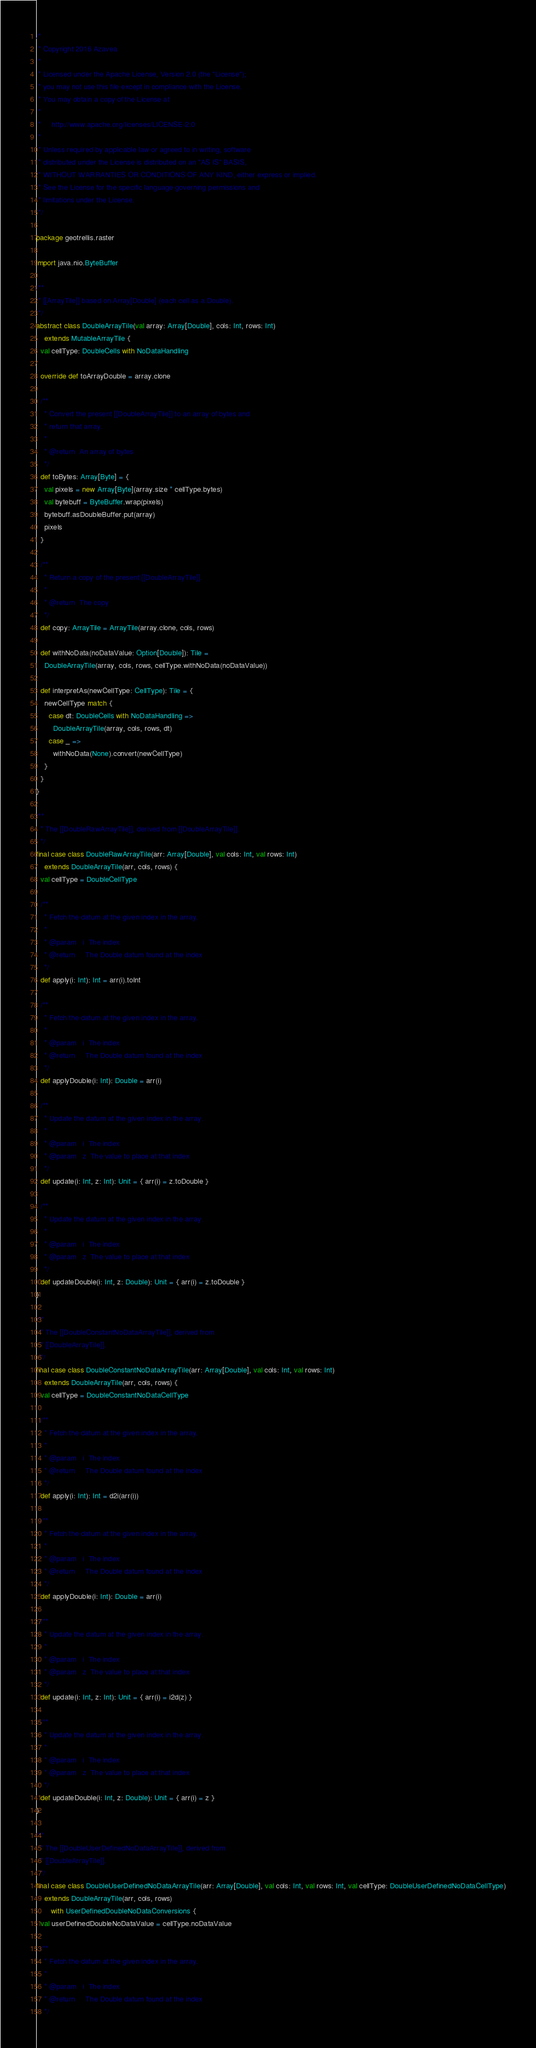Convert code to text. <code><loc_0><loc_0><loc_500><loc_500><_Scala_>/*
 * Copyright 2016 Azavea
 *
 * Licensed under the Apache License, Version 2.0 (the "License");
 * you may not use this file except in compliance with the License.
 * You may obtain a copy of the License at
 *
 *     http://www.apache.org/licenses/LICENSE-2.0
 *
 * Unless required by applicable law or agreed to in writing, software
 * distributed under the License is distributed on an "AS IS" BASIS,
 * WITHOUT WARRANTIES OR CONDITIONS OF ANY KIND, either express or implied.
 * See the License for the specific language governing permissions and
 * limitations under the License.
 */

package geotrellis.raster

import java.nio.ByteBuffer

/**
 * [[ArrayTile]] based on Array[Double] (each cell as a Double).
 */
abstract class DoubleArrayTile(val array: Array[Double], cols: Int, rows: Int)
    extends MutableArrayTile {
  val cellType: DoubleCells with NoDataHandling

  override def toArrayDouble = array.clone

  /**
    * Convert the present [[DoubleArrayTile]] to an array of bytes and
    * return that array.
    *
    * @return  An array of bytes
    */
  def toBytes: Array[Byte] = {
    val pixels = new Array[Byte](array.size * cellType.bytes)
    val bytebuff = ByteBuffer.wrap(pixels)
    bytebuff.asDoubleBuffer.put(array)
    pixels
  }

  /**
    * Return a copy of the present [[DoubleArrayTile]].
    *
    * @return  The copy
    */
  def copy: ArrayTile = ArrayTile(array.clone, cols, rows)

  def withNoData(noDataValue: Option[Double]): Tile =
    DoubleArrayTile(array, cols, rows, cellType.withNoData(noDataValue))

  def interpretAs(newCellType: CellType): Tile = {
    newCellType match {
      case dt: DoubleCells with NoDataHandling =>
        DoubleArrayTile(array, cols, rows, dt)
      case _ =>
        withNoData(None).convert(newCellType)
    }
  }
}

/**
  * The [[DoubleRawArrayTile]], derived from [[DoubleArrayTile]].
  */
final case class DoubleRawArrayTile(arr: Array[Double], val cols: Int, val rows: Int)
    extends DoubleArrayTile(arr, cols, rows) {
  val cellType = DoubleCellType

  /**
    * Fetch the datum at the given index in the array.
    *
    * @param   i  The index
    * @return     The Double datum found at the index
    */
  def apply(i: Int): Int = arr(i).toInt

  /**
    * Fetch the datum at the given index in the array.
    *
    * @param   i  The index
    * @return     The Double datum found at the index
    */
  def applyDouble(i: Int): Double = arr(i)

  /**
    * Update the datum at the given index in the array.
    *
    * @param   i  The index
    * @param   z  The value to place at that index
    */
  def update(i: Int, z: Int): Unit = { arr(i) = z.toDouble }

  /**
    * Update the datum at the given index in the array.
    *
    * @param   i  The index
    * @param   z  The value to place at that index
    */
  def updateDouble(i: Int, z: Double): Unit = { arr(i) = z.toDouble }
}

/**
  * The [[DoubleConstantNoDataArrayTile]], derived from
  * [[DoubleArrayTile]].
  */
final case class DoubleConstantNoDataArrayTile(arr: Array[Double], val cols: Int, val rows: Int)
    extends DoubleArrayTile(arr, cols, rows) {
  val cellType = DoubleConstantNoDataCellType

  /**
    * Fetch the datum at the given index in the array.
    *
    * @param   i  The index
    * @return     The Double datum found at the index
    */
  def apply(i: Int): Int = d2i(arr(i))

  /**
    * Fetch the datum at the given index in the array.
    *
    * @param   i  The index
    * @return     The Double datum found at the index
    */
  def applyDouble(i: Int): Double = arr(i)

  /**
    * Update the datum at the given index in the array.
    *
    * @param   i  The index
    * @param   z  The value to place at that index
    */
  def update(i: Int, z: Int): Unit = { arr(i) = i2d(z) }

  /**
    * Update the datum at the given index in the array.
    *
    * @param   i  The index
    * @param   z  The value to place at that index
    */
  def updateDouble(i: Int, z: Double): Unit = { arr(i) = z }
}

/**
  * The [[DoubleUserDefinedNoDataArrayTile]], derived from
  * [[DoubleArrayTile]].
  */
final case class DoubleUserDefinedNoDataArrayTile(arr: Array[Double], val cols: Int, val rows: Int, val cellType: DoubleUserDefinedNoDataCellType)
    extends DoubleArrayTile(arr, cols, rows)
       with UserDefinedDoubleNoDataConversions {
  val userDefinedDoubleNoDataValue = cellType.noDataValue

  /**
    * Fetch the datum at the given index in the array.
    *
    * @param   i  The index
    * @return     The Double datum found at the index
    */</code> 